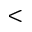<formula> <loc_0><loc_0><loc_500><loc_500><</formula> 